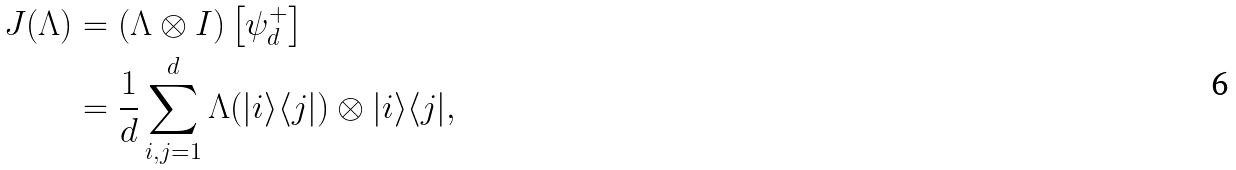Convert formula to latex. <formula><loc_0><loc_0><loc_500><loc_500>J ( \Lambda ) & = \left ( \Lambda \otimes I \right ) \left [ \psi _ { d } ^ { + } \right ] \\ & = \frac { 1 } { d } \sum _ { i , j = 1 } ^ { d } \Lambda ( | i \rangle \langle j | ) \otimes | i \rangle \langle j | ,</formula> 